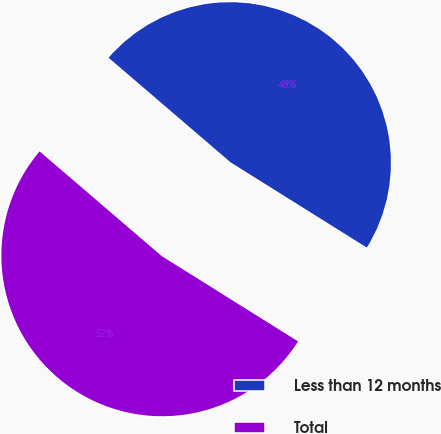<chart> <loc_0><loc_0><loc_500><loc_500><pie_chart><fcel>Less than 12 months<fcel>Total<nl><fcel>47.62%<fcel>52.38%<nl></chart> 